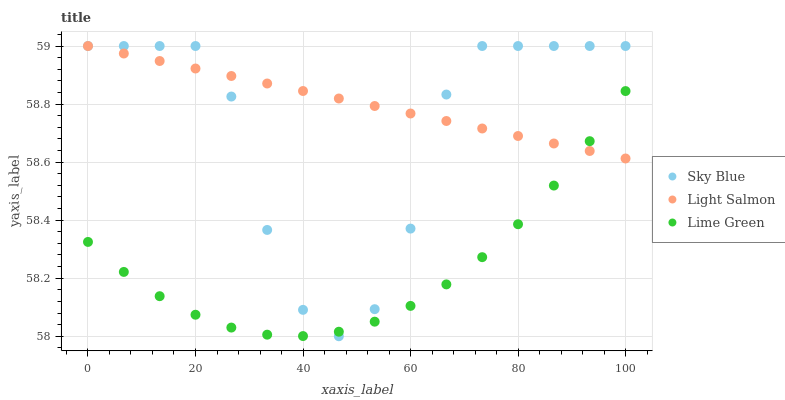Does Lime Green have the minimum area under the curve?
Answer yes or no. Yes. Does Light Salmon have the maximum area under the curve?
Answer yes or no. Yes. Does Light Salmon have the minimum area under the curve?
Answer yes or no. No. Does Lime Green have the maximum area under the curve?
Answer yes or no. No. Is Light Salmon the smoothest?
Answer yes or no. Yes. Is Sky Blue the roughest?
Answer yes or no. Yes. Is Lime Green the smoothest?
Answer yes or no. No. Is Lime Green the roughest?
Answer yes or no. No. Does Sky Blue have the lowest value?
Answer yes or no. Yes. Does Lime Green have the lowest value?
Answer yes or no. No. Does Light Salmon have the highest value?
Answer yes or no. Yes. Does Lime Green have the highest value?
Answer yes or no. No. Does Lime Green intersect Sky Blue?
Answer yes or no. Yes. Is Lime Green less than Sky Blue?
Answer yes or no. No. Is Lime Green greater than Sky Blue?
Answer yes or no. No. 